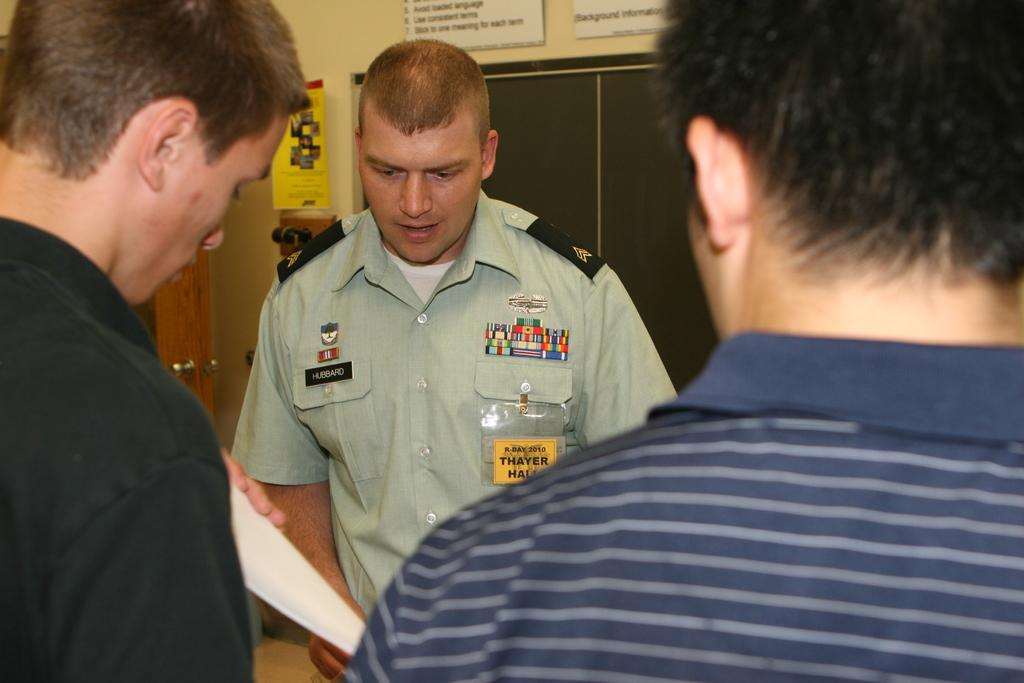<image>
Describe the image concisely. A man in a uniform with a HUBBARD tag on his shirt is with two other men. 